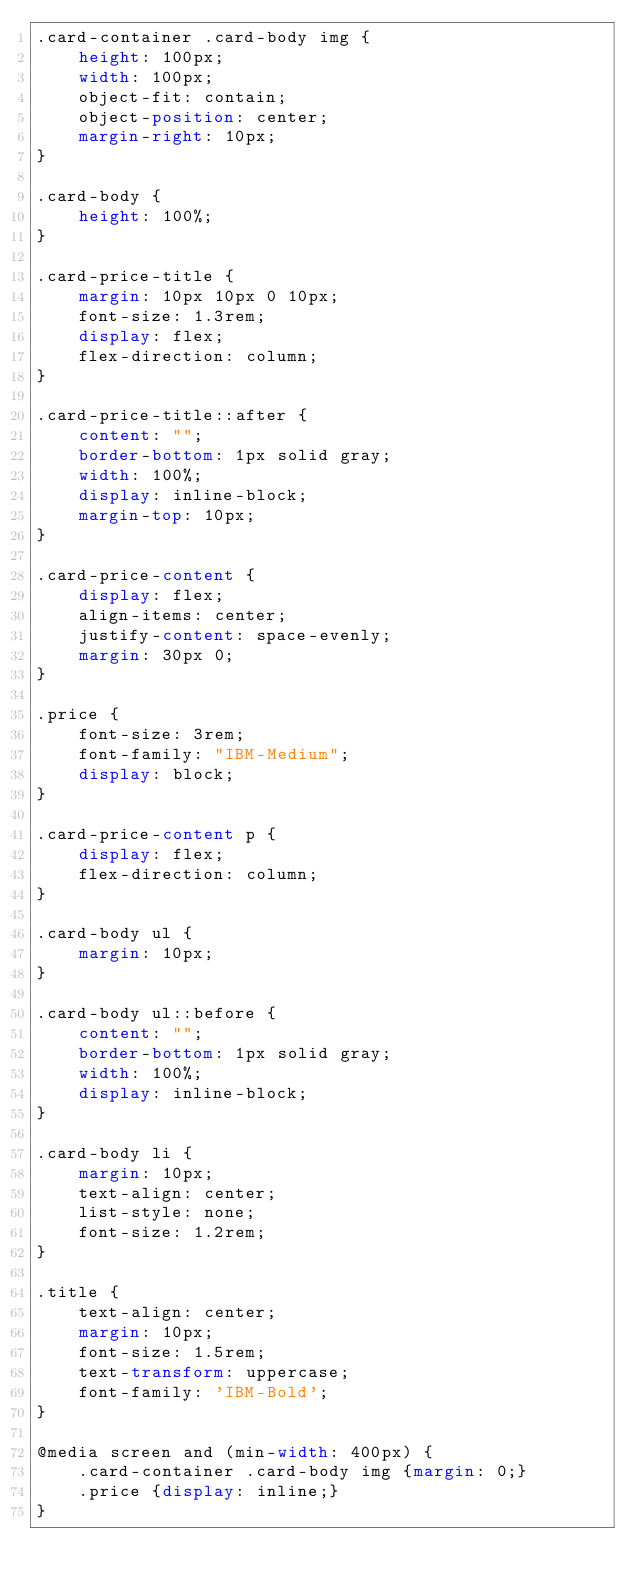<code> <loc_0><loc_0><loc_500><loc_500><_CSS_>.card-container .card-body img {
    height: 100px;
    width: 100px;
    object-fit: contain;
    object-position: center;
    margin-right: 10px;
}

.card-body {
    height: 100%;
}

.card-price-title {
    margin: 10px 10px 0 10px;
    font-size: 1.3rem;
    display: flex;
    flex-direction: column;
}

.card-price-title::after {
    content: "";
    border-bottom: 1px solid gray;
    width: 100%;
    display: inline-block;
    margin-top: 10px;
}

.card-price-content {
    display: flex;
    align-items: center;
    justify-content: space-evenly;
    margin: 30px 0;
}

.price {
    font-size: 3rem;
    font-family: "IBM-Medium";
    display: block;
}

.card-price-content p {
    display: flex;
    flex-direction: column;
}

.card-body ul {
    margin: 10px;
}

.card-body ul::before {
    content: "";
    border-bottom: 1px solid gray;
    width: 100%;
    display: inline-block;
}

.card-body li {
    margin: 10px;
    text-align: center;
    list-style: none;
    font-size: 1.2rem;
}

.title {
    text-align: center;
    margin: 10px;
    font-size: 1.5rem;
    text-transform: uppercase;
    font-family: 'IBM-Bold';
}

@media screen and (min-width: 400px) {
    .card-container .card-body img {margin: 0;}
    .price {display: inline;}
}</code> 